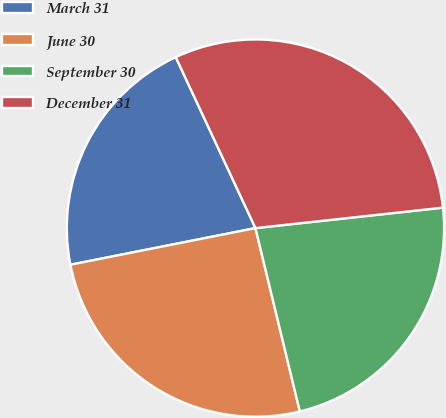Convert chart to OTSL. <chart><loc_0><loc_0><loc_500><loc_500><pie_chart><fcel>March 31<fcel>June 30<fcel>September 30<fcel>December 31<nl><fcel>21.17%<fcel>25.67%<fcel>22.95%<fcel>30.21%<nl></chart> 